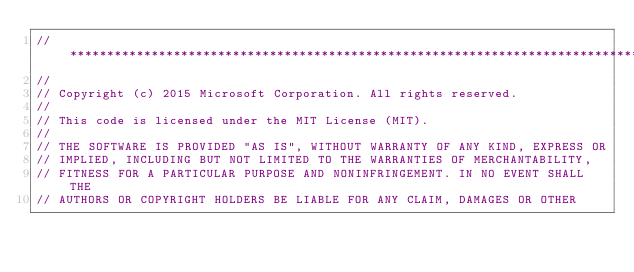Convert code to text. <code><loc_0><loc_0><loc_500><loc_500><_ObjectiveC_>//******************************************************************************
//
// Copyright (c) 2015 Microsoft Corporation. All rights reserved.
//
// This code is licensed under the MIT License (MIT).
//
// THE SOFTWARE IS PROVIDED "AS IS", WITHOUT WARRANTY OF ANY KIND, EXPRESS OR
// IMPLIED, INCLUDING BUT NOT LIMITED TO THE WARRANTIES OF MERCHANTABILITY,
// FITNESS FOR A PARTICULAR PURPOSE AND NONINFRINGEMENT. IN NO EVENT SHALL THE
// AUTHORS OR COPYRIGHT HOLDERS BE LIABLE FOR ANY CLAIM, DAMAGES OR OTHER</code> 